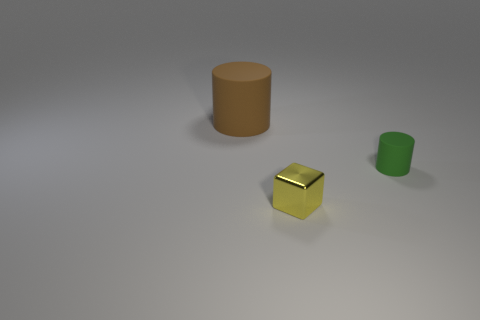Add 1 large rubber cylinders. How many objects exist? 4 Subtract 1 cylinders. How many cylinders are left? 1 Subtract all large green shiny objects. Subtract all matte cylinders. How many objects are left? 1 Add 2 tiny objects. How many tiny objects are left? 4 Add 3 yellow shiny blocks. How many yellow shiny blocks exist? 4 Subtract 0 green cubes. How many objects are left? 3 Subtract all cubes. How many objects are left? 2 Subtract all red cylinders. Subtract all red blocks. How many cylinders are left? 2 Subtract all cyan cubes. How many purple cylinders are left? 0 